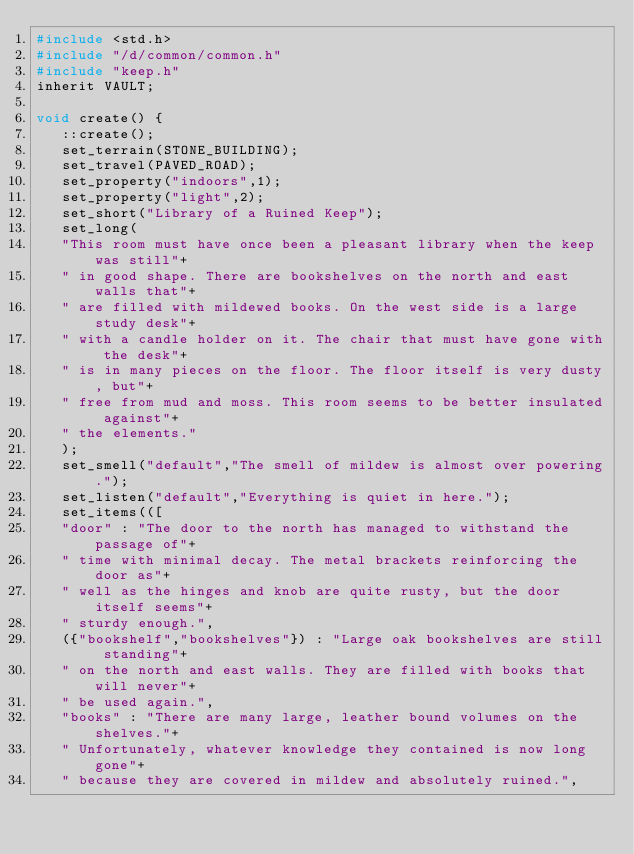<code> <loc_0><loc_0><loc_500><loc_500><_C_>#include <std.h>
#include "/d/common/common.h"
#include "keep.h"
inherit VAULT;

void create() {
   ::create();
   set_terrain(STONE_BUILDING);
   set_travel(PAVED_ROAD);
   set_property("indoors",1);
   set_property("light",2);
   set_short("Library of a Ruined Keep");
   set_long(
   "This room must have once been a pleasant library when the keep was still"+
   " in good shape. There are bookshelves on the north and east walls that"+
   " are filled with mildewed books. On the west side is a large study desk"+
   " with a candle holder on it. The chair that must have gone with the desk"+
   " is in many pieces on the floor. The floor itself is very dusty, but"+
   " free from mud and moss. This room seems to be better insulated against"+
   " the elements."
   );
   set_smell("default","The smell of mildew is almost over powering.");
   set_listen("default","Everything is quiet in here.");
   set_items(([
   "door" : "The door to the north has managed to withstand the passage of"+
   " time with minimal decay. The metal brackets reinforcing the door as"+
   " well as the hinges and knob are quite rusty, but the door itself seems"+
   " sturdy enough.",
   ({"bookshelf","bookshelves"}) : "Large oak bookshelves are still standing"+
   " on the north and east walls. They are filled with books that will never"+
   " be used again.",
   "books" : "There are many large, leather bound volumes on the shelves."+
   " Unfortunately, whatever knowledge they contained is now long gone"+
   " because they are covered in mildew and absolutely ruined.",</code> 